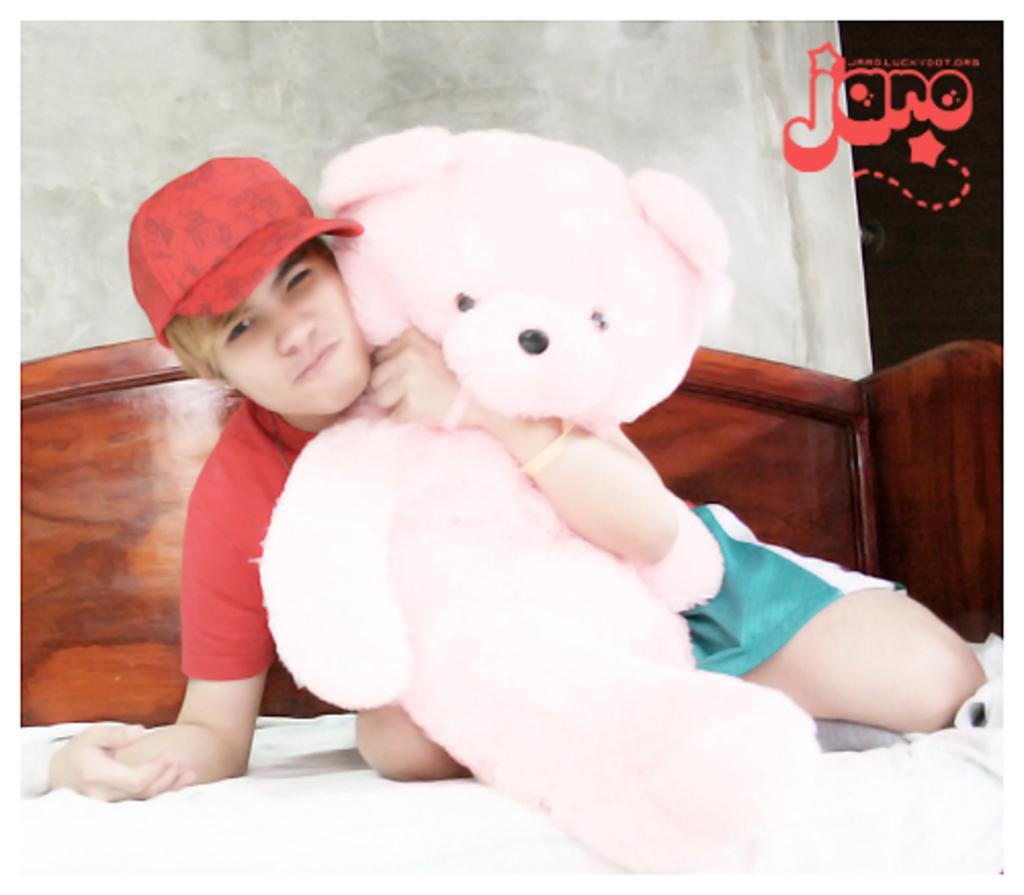Who is present in the image? There is a person in the image. What is the person wearing on their head? The person is wearing a cap. What object is the person holding in the image? The person is holding a teddy bear. Where is the person located in the image? The person is visible on a bed. What can be seen in the background of the image? There is a wall in the background of the image. What type of rule does the person in the image enforce? There is no indication in the image that the person is enforcing any rules, as the image only shows a person on a bed holding a teddy bear. 